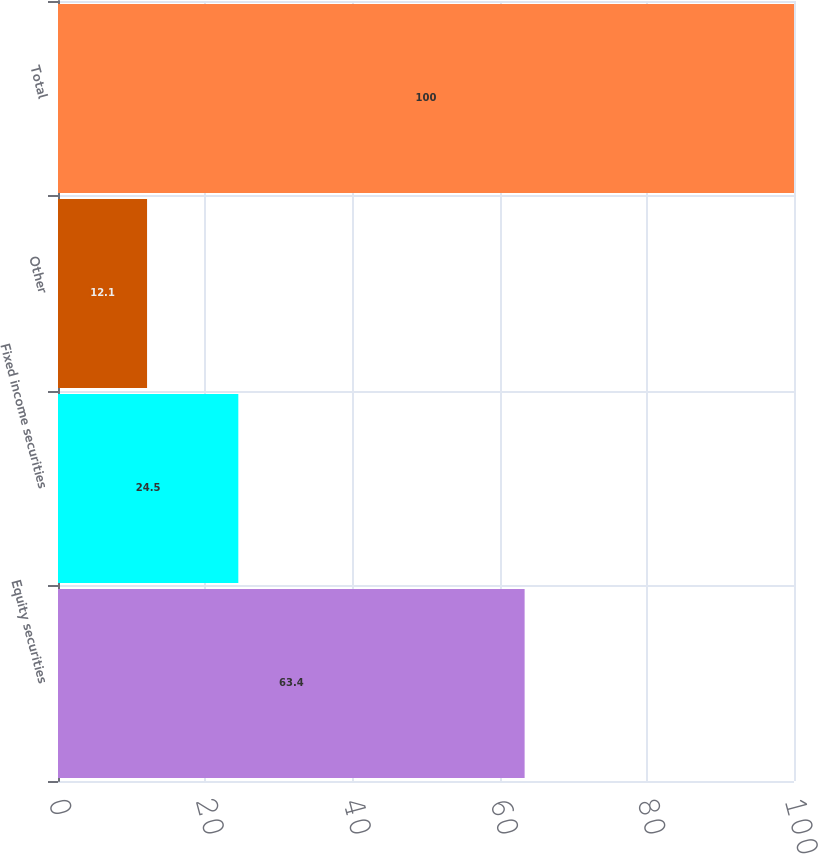<chart> <loc_0><loc_0><loc_500><loc_500><bar_chart><fcel>Equity securities<fcel>Fixed income securities<fcel>Other<fcel>Total<nl><fcel>63.4<fcel>24.5<fcel>12.1<fcel>100<nl></chart> 